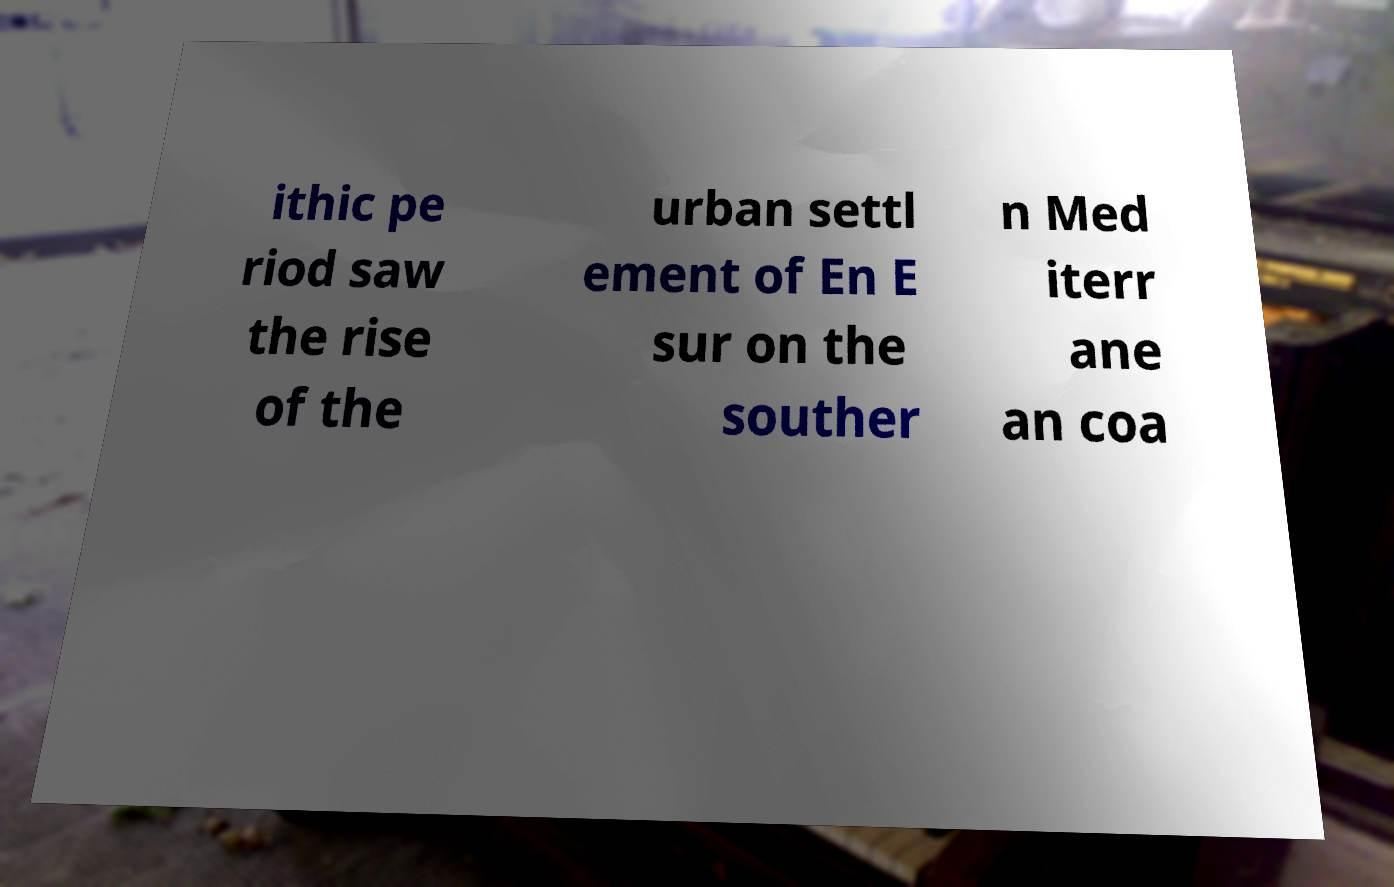There's text embedded in this image that I need extracted. Can you transcribe it verbatim? ithic pe riod saw the rise of the urban settl ement of En E sur on the souther n Med iterr ane an coa 